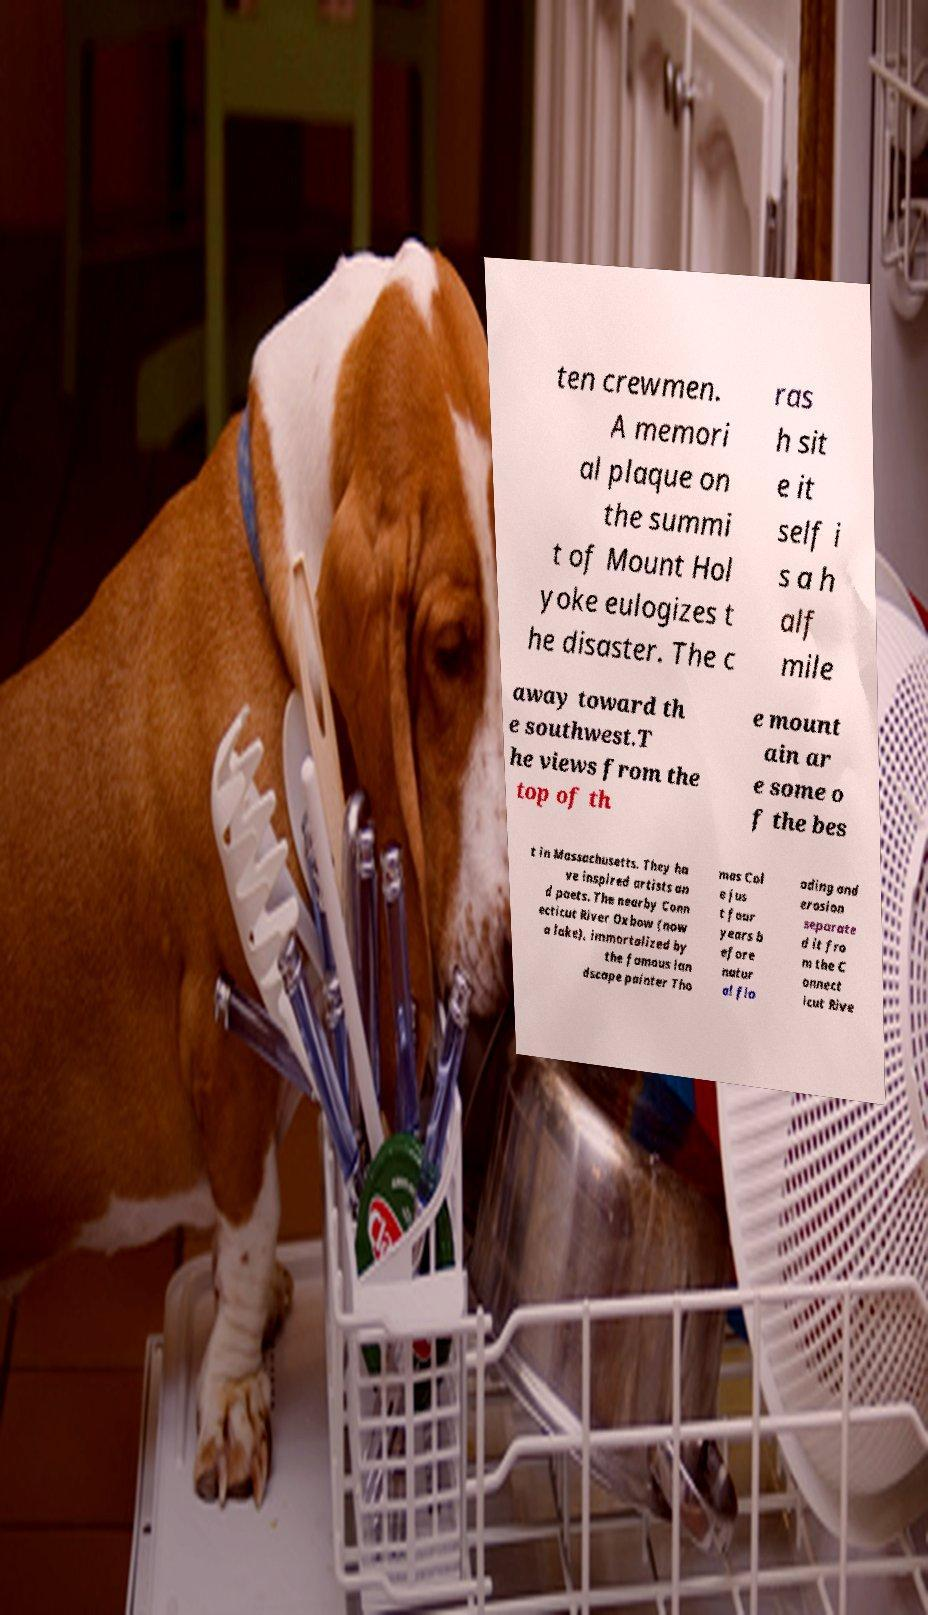There's text embedded in this image that I need extracted. Can you transcribe it verbatim? ten crewmen. A memori al plaque on the summi t of Mount Hol yoke eulogizes t he disaster. The c ras h sit e it self i s a h alf mile away toward th e southwest.T he views from the top of th e mount ain ar e some o f the bes t in Massachusetts. They ha ve inspired artists an d poets. The nearby Conn ecticut River Oxbow (now a lake), immortalized by the famous lan dscape painter Tho mas Col e jus t four years b efore natur al flo oding and erosion separate d it fro m the C onnect icut Rive 